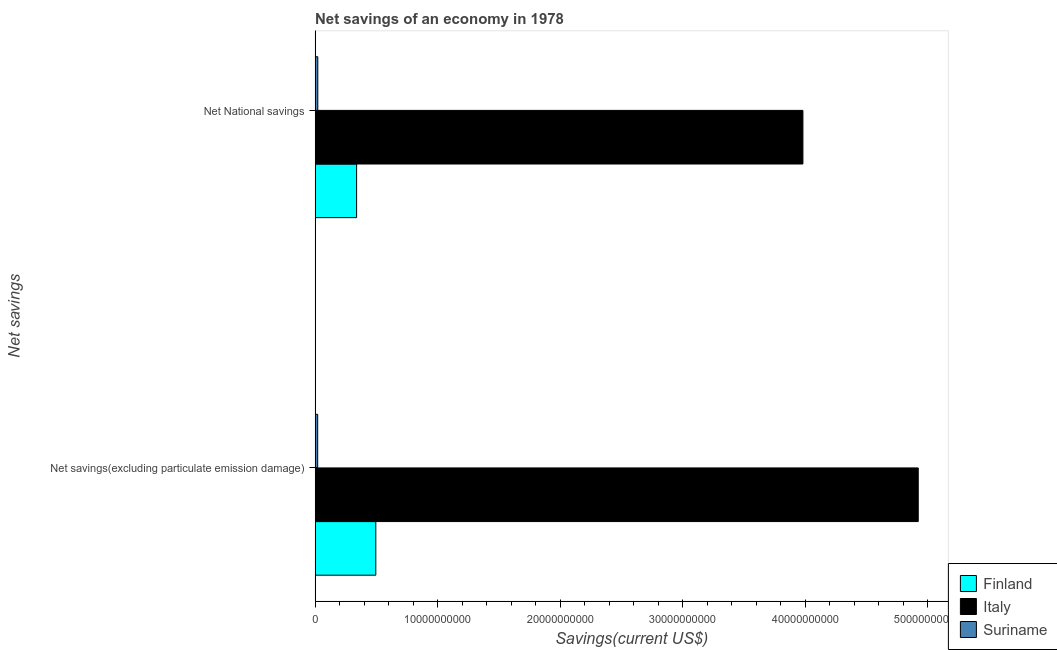How many groups of bars are there?
Keep it short and to the point. 2. Are the number of bars per tick equal to the number of legend labels?
Offer a very short reply. Yes. Are the number of bars on each tick of the Y-axis equal?
Provide a short and direct response. Yes. How many bars are there on the 2nd tick from the top?
Provide a succinct answer. 3. How many bars are there on the 1st tick from the bottom?
Keep it short and to the point. 3. What is the label of the 2nd group of bars from the top?
Your answer should be compact. Net savings(excluding particulate emission damage). What is the net national savings in Finland?
Make the answer very short. 3.39e+09. Across all countries, what is the maximum net national savings?
Offer a terse response. 3.98e+1. Across all countries, what is the minimum net savings(excluding particulate emission damage)?
Make the answer very short. 2.11e+08. In which country was the net national savings minimum?
Offer a terse response. Suriname. What is the total net savings(excluding particulate emission damage) in the graph?
Offer a terse response. 5.44e+1. What is the difference between the net savings(excluding particulate emission damage) in Finland and that in Italy?
Offer a terse response. -4.43e+1. What is the difference between the net savings(excluding particulate emission damage) in Suriname and the net national savings in Italy?
Provide a short and direct response. -3.96e+1. What is the average net national savings per country?
Your response must be concise. 1.45e+1. What is the difference between the net national savings and net savings(excluding particulate emission damage) in Finland?
Your response must be concise. -1.57e+09. In how many countries, is the net savings(excluding particulate emission damage) greater than 40000000000 US$?
Provide a short and direct response. 1. What is the ratio of the net national savings in Italy to that in Suriname?
Your response must be concise. 181.03. What does the 2nd bar from the top in Net savings(excluding particulate emission damage) represents?
Give a very brief answer. Italy. What does the 2nd bar from the bottom in Net National savings represents?
Offer a terse response. Italy. How many bars are there?
Make the answer very short. 6. Are all the bars in the graph horizontal?
Offer a very short reply. Yes. How many countries are there in the graph?
Your response must be concise. 3. What is the difference between two consecutive major ticks on the X-axis?
Your answer should be compact. 1.00e+1. Are the values on the major ticks of X-axis written in scientific E-notation?
Keep it short and to the point. No. Does the graph contain any zero values?
Provide a succinct answer. No. How many legend labels are there?
Keep it short and to the point. 3. How are the legend labels stacked?
Offer a very short reply. Vertical. What is the title of the graph?
Your answer should be compact. Net savings of an economy in 1978. What is the label or title of the X-axis?
Keep it short and to the point. Savings(current US$). What is the label or title of the Y-axis?
Offer a very short reply. Net savings. What is the Savings(current US$) in Finland in Net savings(excluding particulate emission damage)?
Provide a short and direct response. 4.95e+09. What is the Savings(current US$) in Italy in Net savings(excluding particulate emission damage)?
Provide a short and direct response. 4.92e+1. What is the Savings(current US$) of Suriname in Net savings(excluding particulate emission damage)?
Your answer should be very brief. 2.11e+08. What is the Savings(current US$) in Finland in Net National savings?
Offer a very short reply. 3.39e+09. What is the Savings(current US$) in Italy in Net National savings?
Provide a short and direct response. 3.98e+1. What is the Savings(current US$) of Suriname in Net National savings?
Offer a very short reply. 2.20e+08. Across all Net savings, what is the maximum Savings(current US$) of Finland?
Provide a short and direct response. 4.95e+09. Across all Net savings, what is the maximum Savings(current US$) in Italy?
Make the answer very short. 4.92e+1. Across all Net savings, what is the maximum Savings(current US$) in Suriname?
Your answer should be very brief. 2.20e+08. Across all Net savings, what is the minimum Savings(current US$) of Finland?
Your answer should be very brief. 3.39e+09. Across all Net savings, what is the minimum Savings(current US$) in Italy?
Ensure brevity in your answer.  3.98e+1. Across all Net savings, what is the minimum Savings(current US$) of Suriname?
Provide a short and direct response. 2.11e+08. What is the total Savings(current US$) of Finland in the graph?
Your response must be concise. 8.34e+09. What is the total Savings(current US$) of Italy in the graph?
Your answer should be compact. 8.90e+1. What is the total Savings(current US$) in Suriname in the graph?
Offer a very short reply. 4.31e+08. What is the difference between the Savings(current US$) in Finland in Net savings(excluding particulate emission damage) and that in Net National savings?
Keep it short and to the point. 1.57e+09. What is the difference between the Savings(current US$) in Italy in Net savings(excluding particulate emission damage) and that in Net National savings?
Give a very brief answer. 9.41e+09. What is the difference between the Savings(current US$) of Suriname in Net savings(excluding particulate emission damage) and that in Net National savings?
Provide a short and direct response. -8.92e+06. What is the difference between the Savings(current US$) in Finland in Net savings(excluding particulate emission damage) and the Savings(current US$) in Italy in Net National savings?
Keep it short and to the point. -3.49e+1. What is the difference between the Savings(current US$) in Finland in Net savings(excluding particulate emission damage) and the Savings(current US$) in Suriname in Net National savings?
Give a very brief answer. 4.73e+09. What is the difference between the Savings(current US$) in Italy in Net savings(excluding particulate emission damage) and the Savings(current US$) in Suriname in Net National savings?
Give a very brief answer. 4.90e+1. What is the average Savings(current US$) of Finland per Net savings?
Provide a short and direct response. 4.17e+09. What is the average Savings(current US$) in Italy per Net savings?
Provide a short and direct response. 4.45e+1. What is the average Savings(current US$) of Suriname per Net savings?
Make the answer very short. 2.15e+08. What is the difference between the Savings(current US$) in Finland and Savings(current US$) in Italy in Net savings(excluding particulate emission damage)?
Your response must be concise. -4.43e+1. What is the difference between the Savings(current US$) of Finland and Savings(current US$) of Suriname in Net savings(excluding particulate emission damage)?
Give a very brief answer. 4.74e+09. What is the difference between the Savings(current US$) in Italy and Savings(current US$) in Suriname in Net savings(excluding particulate emission damage)?
Your answer should be very brief. 4.90e+1. What is the difference between the Savings(current US$) in Finland and Savings(current US$) in Italy in Net National savings?
Provide a short and direct response. -3.64e+1. What is the difference between the Savings(current US$) in Finland and Savings(current US$) in Suriname in Net National savings?
Make the answer very short. 3.17e+09. What is the difference between the Savings(current US$) in Italy and Savings(current US$) in Suriname in Net National savings?
Your answer should be compact. 3.96e+1. What is the ratio of the Savings(current US$) of Finland in Net savings(excluding particulate emission damage) to that in Net National savings?
Your answer should be very brief. 1.46. What is the ratio of the Savings(current US$) in Italy in Net savings(excluding particulate emission damage) to that in Net National savings?
Ensure brevity in your answer.  1.24. What is the ratio of the Savings(current US$) of Suriname in Net savings(excluding particulate emission damage) to that in Net National savings?
Give a very brief answer. 0.96. What is the difference between the highest and the second highest Savings(current US$) in Finland?
Keep it short and to the point. 1.57e+09. What is the difference between the highest and the second highest Savings(current US$) in Italy?
Your answer should be compact. 9.41e+09. What is the difference between the highest and the second highest Savings(current US$) of Suriname?
Keep it short and to the point. 8.92e+06. What is the difference between the highest and the lowest Savings(current US$) of Finland?
Provide a succinct answer. 1.57e+09. What is the difference between the highest and the lowest Savings(current US$) in Italy?
Offer a very short reply. 9.41e+09. What is the difference between the highest and the lowest Savings(current US$) in Suriname?
Your response must be concise. 8.92e+06. 